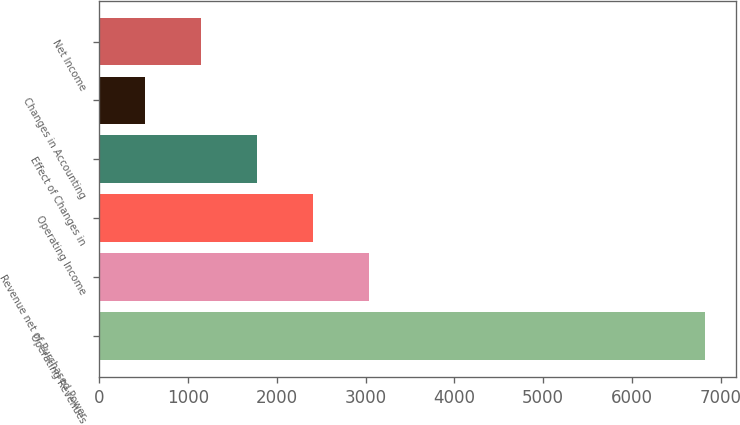Convert chart. <chart><loc_0><loc_0><loc_500><loc_500><bar_chart><fcel>Operating Revenues<fcel>Revenue net of Purchased Power<fcel>Operating Income<fcel>Effect of Changes in<fcel>Changes in Accounting<fcel>Net Income<nl><fcel>6826<fcel>3037.6<fcel>2406.2<fcel>1774.8<fcel>512<fcel>1143.4<nl></chart> 